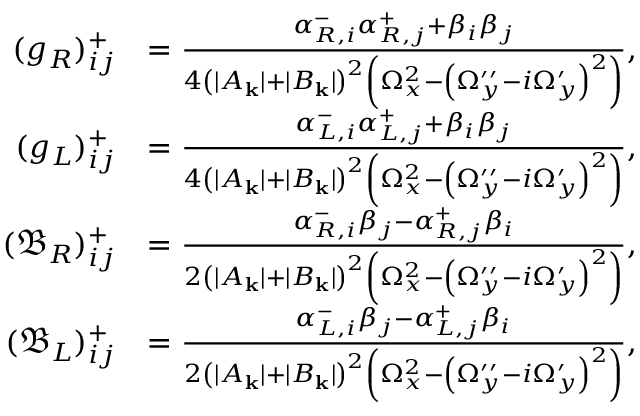<formula> <loc_0><loc_0><loc_500><loc_500>\begin{array} { r l } { ( g _ { R } ) _ { i j } ^ { + } } & { = \frac { \alpha _ { R , i } ^ { - } \alpha _ { R , j } ^ { + } + \beta _ { i } \beta _ { j } } { 4 { \left ( | A _ { k } | + | B _ { k } | \right ) } ^ { 2 } \left ( \Omega _ { x } ^ { 2 } - { \left ( \Omega _ { y } ^ { \prime \prime } - i \Omega _ { y } ^ { \prime } \right ) } ^ { 2 } \right ) } , } \\ { ( g _ { L } ) _ { i j } ^ { + } } & { = \frac { \alpha _ { L , i } ^ { - } \alpha _ { L , j } ^ { + } + \beta _ { i } \beta _ { j } } { 4 { \left ( | A _ { k } | + | B _ { k } | \right ) } ^ { 2 } \left ( \Omega _ { x } ^ { 2 } - { \left ( \Omega _ { y } ^ { \prime \prime } - i \Omega _ { y } ^ { \prime } \right ) } ^ { 2 } \right ) } , } \\ { ( \mathfrak { B } _ { R } ) _ { i j } ^ { + } } & { = \frac { \alpha _ { R , i } ^ { - } \beta _ { j } - \alpha _ { R , j } ^ { + } \beta _ { i } } { 2 { \left ( | A _ { k } | + | B _ { k } | \right ) } ^ { 2 } \left ( \Omega _ { x } ^ { 2 } - { \left ( \Omega _ { y } ^ { \prime \prime } - i \Omega _ { y } ^ { \prime } \right ) } ^ { 2 } \right ) } , } \\ { ( \mathfrak { B } _ { L } ) _ { i j } ^ { + } } & { = \frac { \alpha _ { L , i } ^ { - } \beta _ { j } - \alpha _ { L , j } ^ { + } \beta _ { i } } { 2 { \left ( | A _ { k } | + | B _ { k } | \right ) } ^ { 2 } \left ( \Omega _ { x } ^ { 2 } - { \left ( \Omega _ { y } ^ { \prime \prime } - i \Omega _ { y } ^ { \prime } \right ) } ^ { 2 } \right ) } , } \end{array}</formula> 